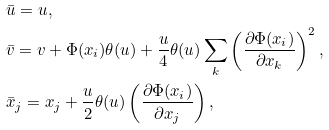Convert formula to latex. <formula><loc_0><loc_0><loc_500><loc_500>& \bar { u } = u , \\ & \bar { v } = v + \Phi ( { x _ { i } } ) \theta ( u ) + \frac { u } { 4 } \theta ( u ) \sum _ { k } \left ( \frac { \partial \Phi ( x _ { i } ) } { \partial x _ { k } } \right ) ^ { 2 } , \\ & \bar { x } _ { j } = x _ { j } + \frac { u } { 2 } \theta ( u ) \left ( \frac { \partial \Phi ( { x _ { i } } ) } { \partial x _ { j } } \right ) ,</formula> 